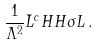Convert formula to latex. <formula><loc_0><loc_0><loc_500><loc_500>\frac { 1 } { \Lambda ^ { 2 } } \bar { L } ^ { c } H H \sigma L \, .</formula> 